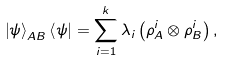<formula> <loc_0><loc_0><loc_500><loc_500>\left | \psi \right \rangle _ { A B } \left \langle \psi \right | = \sum _ { i = 1 } ^ { k } \lambda _ { i } \left ( \rho _ { A } ^ { i } \otimes \rho _ { B } ^ { i } \right ) ,</formula> 